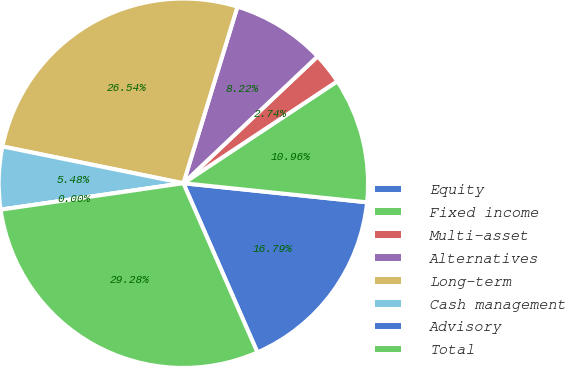Convert chart to OTSL. <chart><loc_0><loc_0><loc_500><loc_500><pie_chart><fcel>Equity<fcel>Fixed income<fcel>Multi-asset<fcel>Alternatives<fcel>Long-term<fcel>Cash management<fcel>Advisory<fcel>Total<nl><fcel>16.79%<fcel>10.96%<fcel>2.74%<fcel>8.22%<fcel>26.54%<fcel>5.48%<fcel>0.0%<fcel>29.28%<nl></chart> 